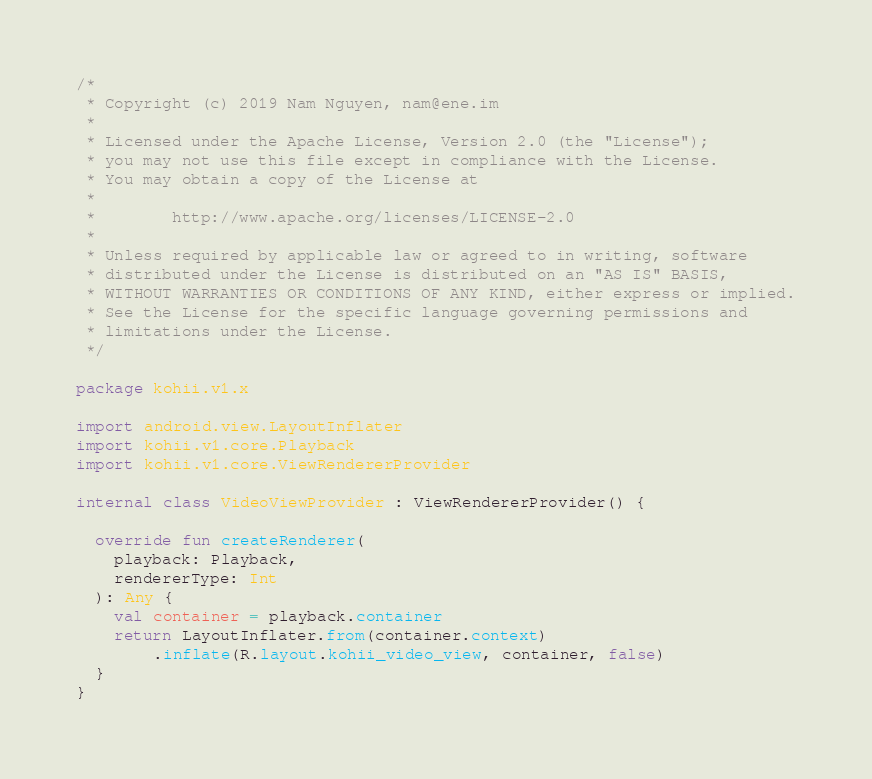<code> <loc_0><loc_0><loc_500><loc_500><_Kotlin_>/*
 * Copyright (c) 2019 Nam Nguyen, nam@ene.im
 *
 * Licensed under the Apache License, Version 2.0 (the "License");
 * you may not use this file except in compliance with the License.
 * You may obtain a copy of the License at
 *
 *        http://www.apache.org/licenses/LICENSE-2.0
 *
 * Unless required by applicable law or agreed to in writing, software
 * distributed under the License is distributed on an "AS IS" BASIS,
 * WITHOUT WARRANTIES OR CONDITIONS OF ANY KIND, either express or implied.
 * See the License for the specific language governing permissions and
 * limitations under the License.
 */

package kohii.v1.x

import android.view.LayoutInflater
import kohii.v1.core.Playback
import kohii.v1.core.ViewRendererProvider

internal class VideoViewProvider : ViewRendererProvider() {

  override fun createRenderer(
    playback: Playback,
    rendererType: Int
  ): Any {
    val container = playback.container
    return LayoutInflater.from(container.context)
        .inflate(R.layout.kohii_video_view, container, false)
  }
}
</code> 